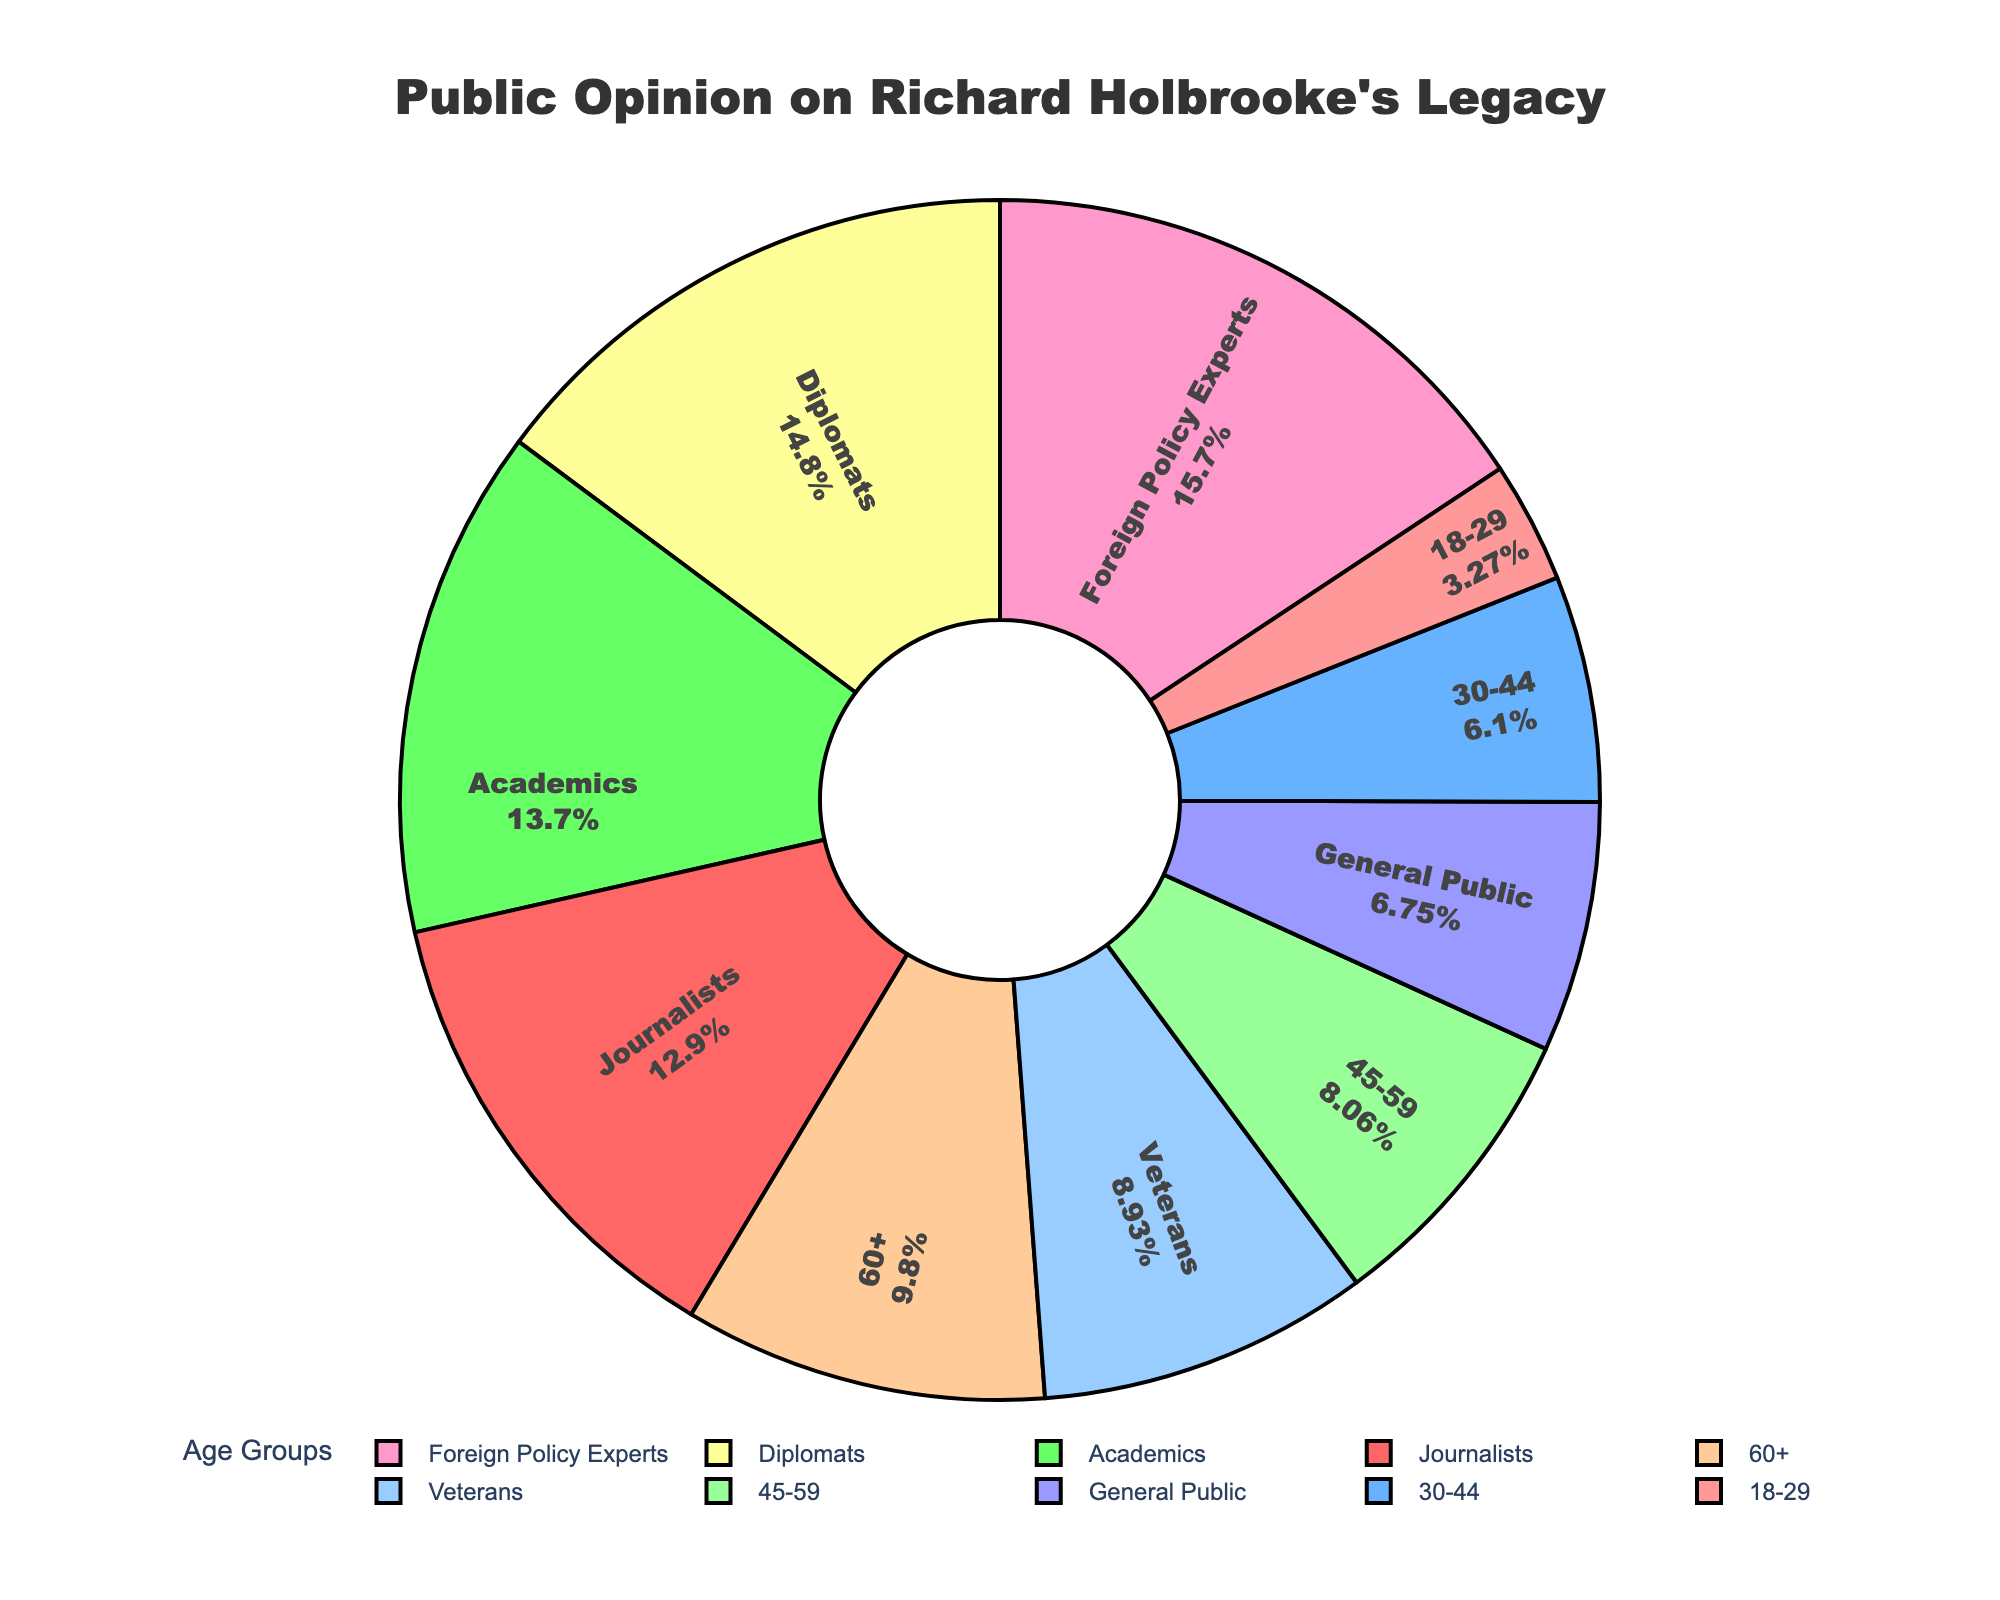What is the approval percentage among foreign policy experts? The pie chart shows various approval percentages among different groups. Locate the label "Foreign Policy Experts" and read the associated percentage, which is clearly stated.
Answer: 72% Which demographic group has the lowest approval percentage? Look at all the sections of the pie chart and identify the one with the smallest percentage. The smallest value on the chart represents the group with the lowest approval.
Answer: 18-29 How does the approval percentage of veterans compare to that of journalists? Locate the percentage values for both veterans and journalists on the pie chart. The approval percentage for veterans is 41%, while for journalists it is 59%.
Answer: Veterans have 18% lower approval than journalists What is the average approval percentage among the 18-29, 30-44, and 45-59 age groups? Sum the approval percentages of these three age groups (15 + 28 + 37) and divide by 3. The total is 80, and 80 divided by 3 equals approximately 26.7.
Answer: 26.7% What is the difference in approval percentage between diplomats and academics? Find the percentages for diplomats and academics on the pie chart. For diplomats, it's 68% and for academics, it's 63%. The difference is calculated as 68 - 63.
Answer: 5% Identify the group with the second-highest approval percentage. Review the approval percentages for all groups and note which one is the highest. Then identify the next highest value, which is 68%, belonging to the diplomats.
Answer: Diplomats Which age group has the highest approval percentage, and what is that percentage? Examine the different age groups shown on the pie chart and look for the one with the highest percentage. The 60+ age group has the highest approval with 45%.
Answer: 60+, 45% By how much does the approval percentage of the general public differ from that of academics? Look at the percentage values for both the general public and academics. Subtract 31% (general public) from 63% (academics) to get the difference.
Answer: 32% If the percentages of approval for foreign policy experts and diplomats are added together, what do we get? Add the approval percentages of foreign policy experts (72%) and diplomats (68%), which equals 140%.
Answer: 140% What is the combined approval percentage of the 30-44 age group and journalists? Sum the percentages of approval for the 30-44 age group (28%) and journalists (59%), resulting in 28 + 59 which equals 87.
Answer: 87% 